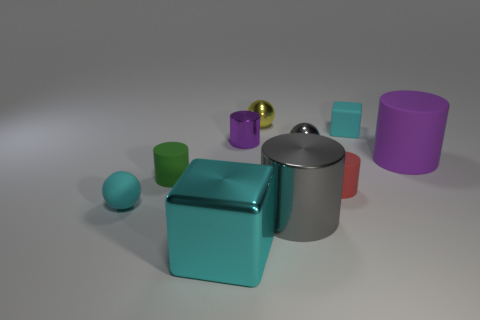How many tiny objects are cyan metallic things or blue matte cylinders?
Keep it short and to the point. 0. There is a small metallic sphere on the right side of the small yellow object; does it have the same color as the metal cylinder that is in front of the small cyan rubber ball?
Your answer should be very brief. Yes. What number of other objects are the same color as the tiny block?
Your answer should be very brief. 2. How many yellow things are big metal objects or big blocks?
Your answer should be very brief. 0. There is a tiny yellow shiny thing; does it have the same shape as the small cyan object that is behind the purple shiny thing?
Offer a terse response. No. What is the shape of the tiny yellow object?
Your answer should be compact. Sphere. What is the material of the gray object that is the same size as the cyan metal cube?
Give a very brief answer. Metal. Is there any other thing that is the same size as the purple matte cylinder?
Make the answer very short. Yes. How many objects are tiny gray shiny balls or cyan cubes left of the yellow ball?
Give a very brief answer. 2. There is a gray cylinder that is the same material as the small yellow thing; what size is it?
Provide a succinct answer. Large. 